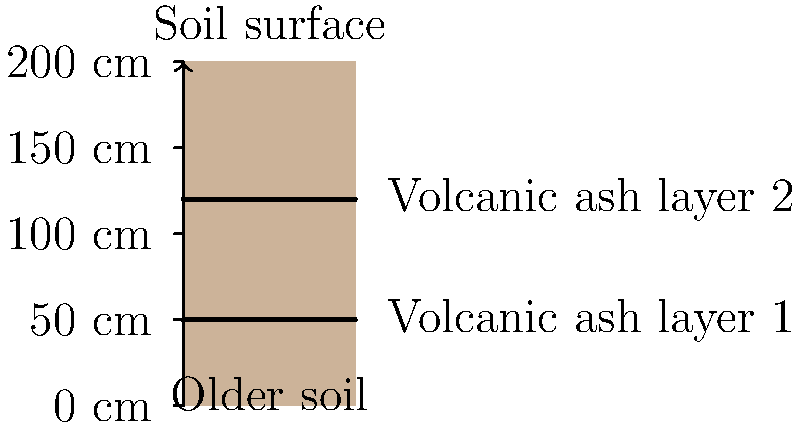In the soil profile shown, two distinct volcanic ash layers are visible. Based on your traditional knowledge, what can these ash layers tell us about the volcanic history of the region, and how might this information be useful for civil engineering projects? 1. Presence of ash layers: The soil profile shows two distinct volcanic ash layers, indicating at least two significant volcanic eruptions in the past.

2. Depth of ash layers: The depths of these layers (approximately 50 cm and 120 cm) suggest different time periods of deposition.

3. Thickness of layers: The thickness of each ash layer can indicate the intensity or proximity of the eruption.

4. Composition: Although not visible in the diagram, the composition of the ash layers can provide information about the type of eruption and the volcano's characteristics.

5. Time intervals: The space between ash layers represents periods of soil formation, indicating the time between eruptions.

6. Historical context: These layers can be correlated with oral histories or other traditional knowledge about past volcanic events.

7. Civil engineering implications:
   a) Soil stability: Volcanic ash layers can affect soil strength and drainage properties.
   b) Seismic response: Different layers can influence how the ground responds to earthquakes.
   c) Foundation design: Understanding the soil profile helps in designing appropriate foundations for structures.
   d) Excavation planning: Knowledge of ash layers can inform excavation techniques and safety measures.
   e) Hazard assessment: The frequency and intensity of past eruptions can help predict future volcanic activity.

8. Cultural significance: These ash layers may be associated with important events or stories in the community's history.

9. Environmental indicators: The presence and characteristics of plants growing in these soils can provide additional information about past climates and ecosystems.
Answer: Volcanic ash layers indicate past eruptions, their timing, and intensity. This information aids in assessing soil stability, seismic response, and potential future volcanic hazards for civil engineering projects. 